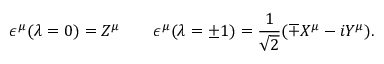Convert formula to latex. <formula><loc_0><loc_0><loc_500><loc_500>\epsilon ^ { \mu } ( \lambda = 0 ) = Z ^ { \mu } \quad \epsilon ^ { \mu } ( \lambda = \pm 1 ) = \frac { 1 } { \sqrt { 2 } } ( \mp X ^ { \mu } - i Y ^ { \mu } ) .</formula> 